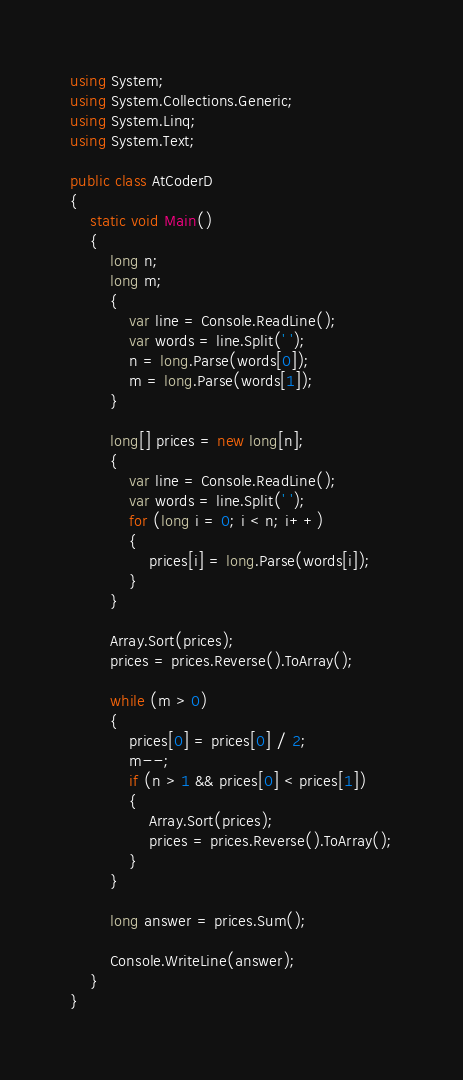Convert code to text. <code><loc_0><loc_0><loc_500><loc_500><_C#_>using System;
using System.Collections.Generic;
using System.Linq;
using System.Text;

public class AtCoderD
{
    static void Main()
    {
        long n;
        long m;
        {
            var line = Console.ReadLine();
            var words = line.Split(' ');
            n = long.Parse(words[0]);
            m = long.Parse(words[1]);
        }

        long[] prices = new long[n];
        {
            var line = Console.ReadLine();
            var words = line.Split(' ');
            for (long i = 0; i < n; i++)
            {
                prices[i] = long.Parse(words[i]);
            }
        }

        Array.Sort(prices);
        prices = prices.Reverse().ToArray();

        while (m > 0)
        {
            prices[0] = prices[0] / 2;
            m--;
            if (n > 1 && prices[0] < prices[1])
            {
                Array.Sort(prices);
                prices = prices.Reverse().ToArray();
            }
        }

        long answer = prices.Sum();

        Console.WriteLine(answer);
    }
}</code> 